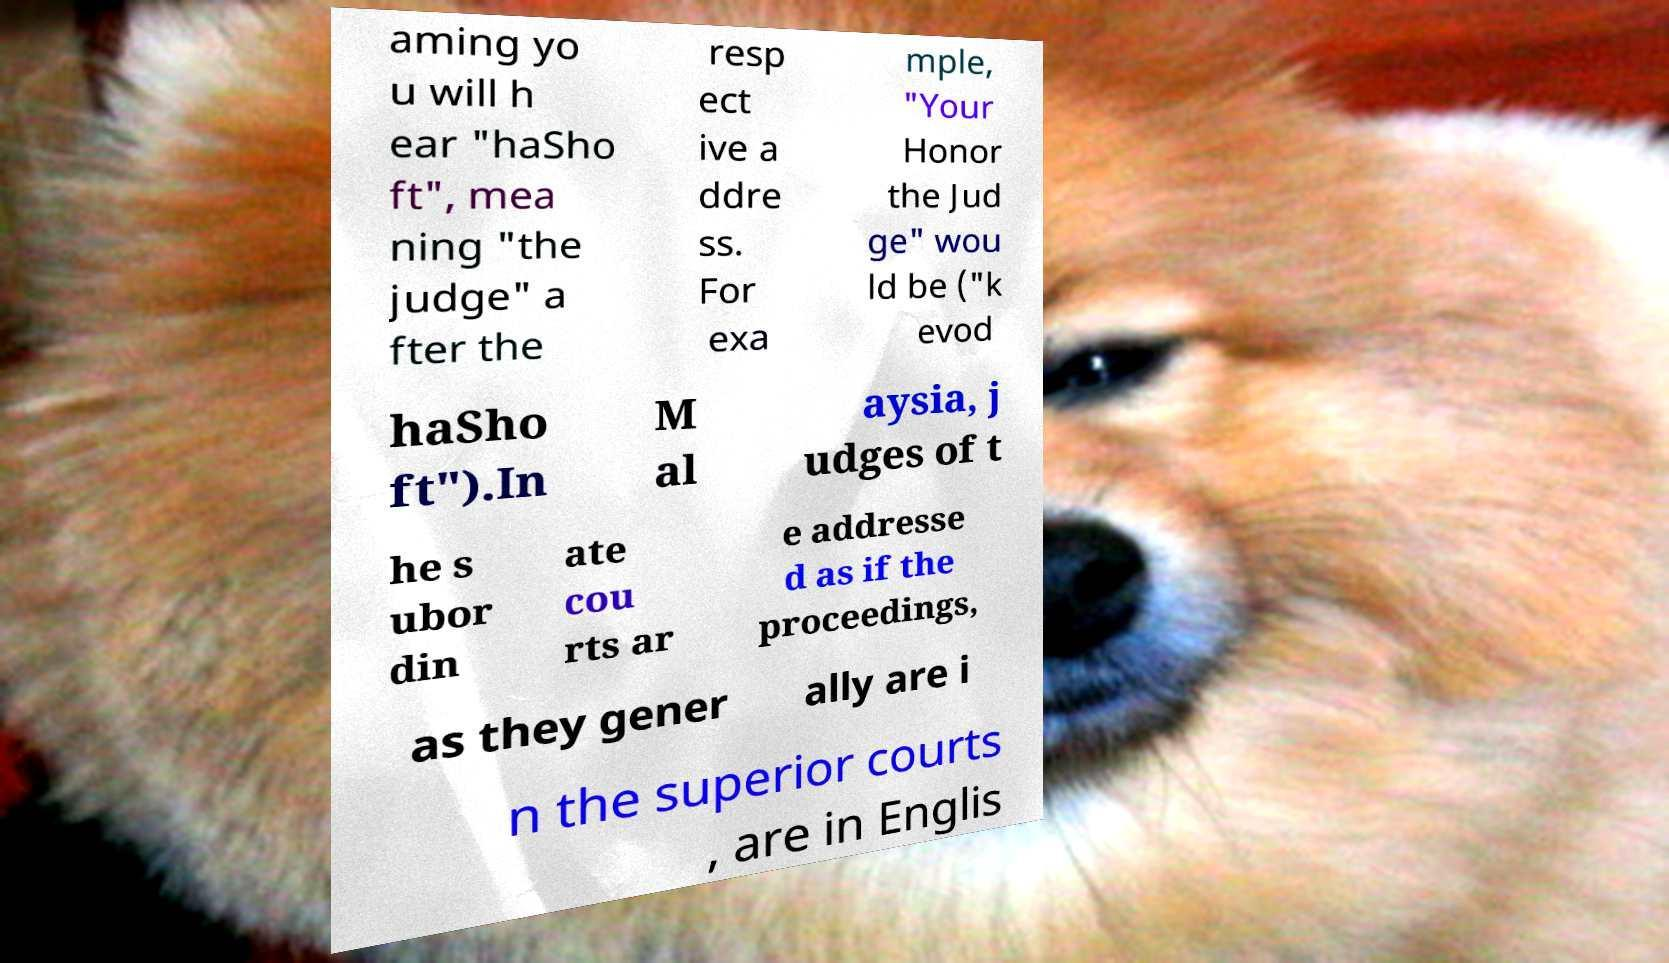Could you extract and type out the text from this image? aming yo u will h ear "haSho ft", mea ning "the judge" a fter the resp ect ive a ddre ss. For exa mple, "Your Honor the Jud ge" wou ld be ("k evod haSho ft").In M al aysia, j udges of t he s ubor din ate cou rts ar e addresse d as if the proceedings, as they gener ally are i n the superior courts , are in Englis 